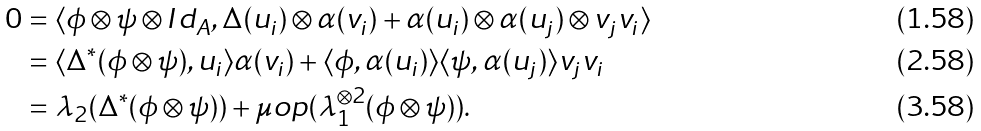<formula> <loc_0><loc_0><loc_500><loc_500>0 & = \langle \phi \otimes \psi \otimes I d _ { A } , \Delta ( u _ { i } ) \otimes \alpha ( v _ { i } ) + \alpha ( u _ { i } ) \otimes \alpha ( u _ { j } ) \otimes v _ { j } v _ { i } \rangle \\ & = \langle \Delta ^ { * } ( \phi \otimes \psi ) , u _ { i } \rangle \alpha ( v _ { i } ) + \langle \phi , \alpha ( u _ { i } ) \rangle \langle \psi , \alpha ( u _ { j } ) \rangle v _ { j } v _ { i } \\ & = \lambda _ { 2 } ( \Delta ^ { * } ( \phi \otimes \psi ) ) + \mu o p ( \lambda _ { 1 } ^ { \otimes 2 } ( \phi \otimes \psi ) ) .</formula> 